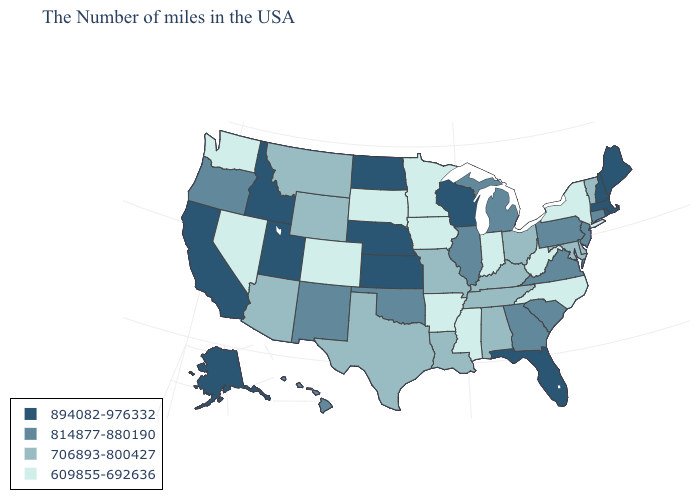Name the states that have a value in the range 706893-800427?
Be succinct. Vermont, Delaware, Maryland, Ohio, Kentucky, Alabama, Tennessee, Louisiana, Missouri, Texas, Wyoming, Montana, Arizona. What is the value of West Virginia?
Answer briefly. 609855-692636. What is the lowest value in states that border Connecticut?
Quick response, please. 609855-692636. Does Vermont have the same value as Idaho?
Be succinct. No. Does Washington have the same value as Colorado?
Answer briefly. Yes. What is the value of Maryland?
Write a very short answer. 706893-800427. What is the value of Illinois?
Be succinct. 814877-880190. Name the states that have a value in the range 706893-800427?
Write a very short answer. Vermont, Delaware, Maryland, Ohio, Kentucky, Alabama, Tennessee, Louisiana, Missouri, Texas, Wyoming, Montana, Arizona. What is the value of Arizona?
Short answer required. 706893-800427. What is the value of West Virginia?
Quick response, please. 609855-692636. Among the states that border Ohio , which have the highest value?
Write a very short answer. Pennsylvania, Michigan. Among the states that border Florida , does Georgia have the highest value?
Write a very short answer. Yes. What is the lowest value in the USA?
Concise answer only. 609855-692636. What is the lowest value in the West?
Answer briefly. 609855-692636. Which states have the lowest value in the USA?
Be succinct. New York, North Carolina, West Virginia, Indiana, Mississippi, Arkansas, Minnesota, Iowa, South Dakota, Colorado, Nevada, Washington. 